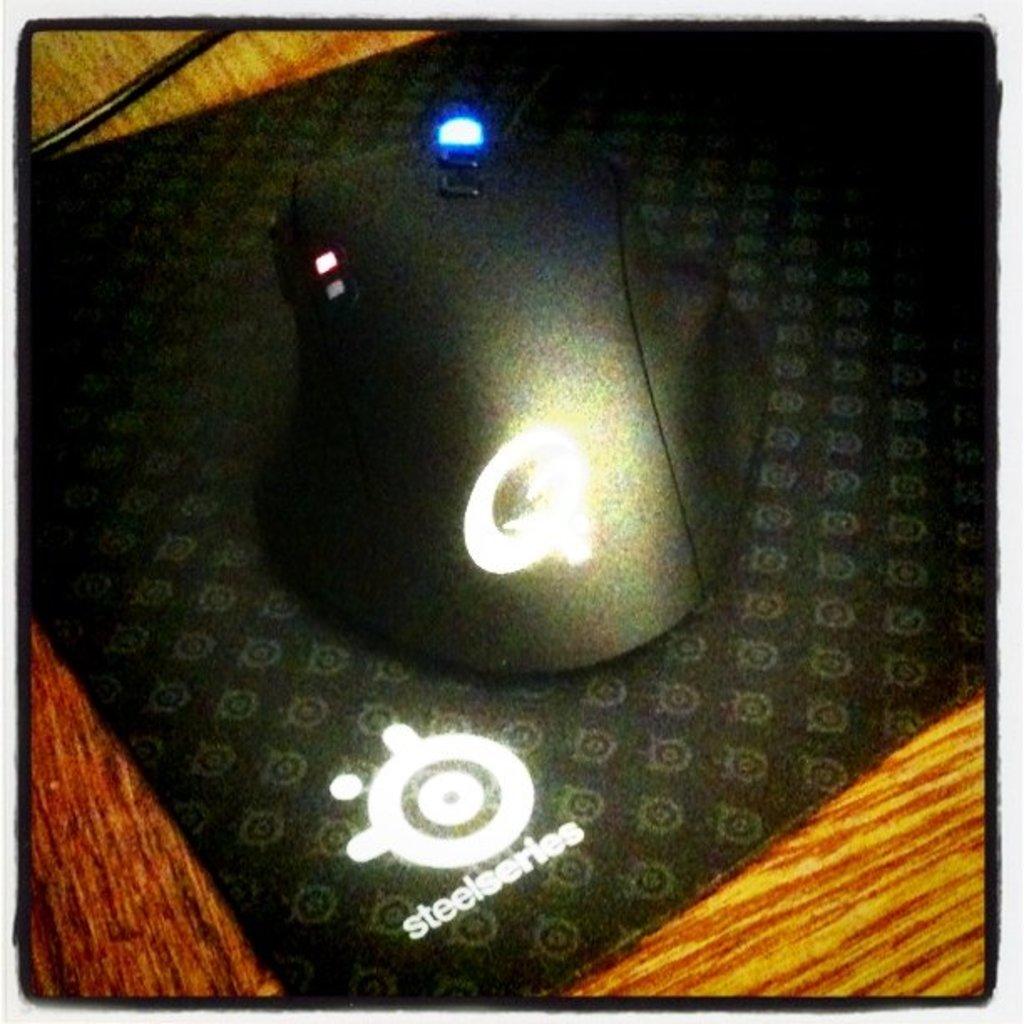What is the name of the mouse?
Your answer should be very brief. Steelseries. What brand is this?
Keep it short and to the point. Steelseries. 